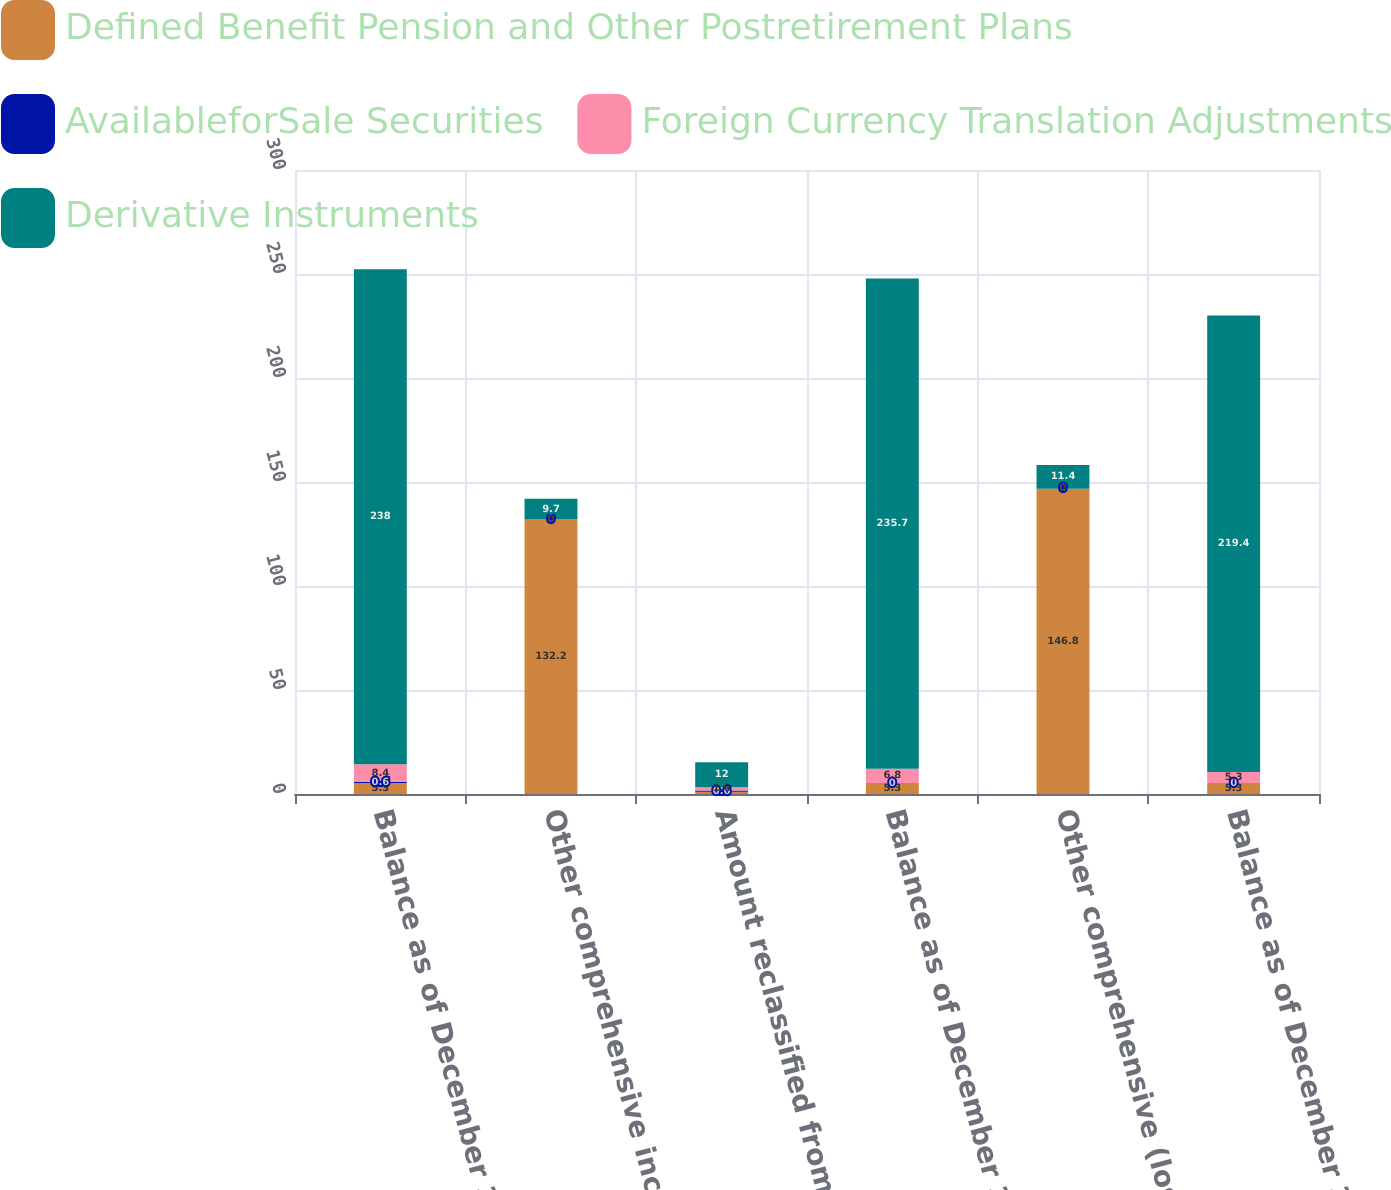Convert chart to OTSL. <chart><loc_0><loc_0><loc_500><loc_500><stacked_bar_chart><ecel><fcel>Balance as of December 31 2016<fcel>Other comprehensive income<fcel>Amount reclassified from<fcel>Balance as of December 31 2017<fcel>Other comprehensive (loss)<fcel>Balance as of December 31 2018<nl><fcel>Defined Benefit Pension and Other Postretirement Plans<fcel>5.3<fcel>132.2<fcel>1.1<fcel>5.3<fcel>146.8<fcel>5.3<nl><fcel>AvailableforSale Securities<fcel>0.6<fcel>0<fcel>0.6<fcel>0<fcel>0<fcel>0<nl><fcel>Foreign Currency Translation Adjustments<fcel>8.4<fcel>0<fcel>1.6<fcel>6.8<fcel>0<fcel>5.3<nl><fcel>Derivative Instruments<fcel>238<fcel>9.7<fcel>12<fcel>235.7<fcel>11.4<fcel>219.4<nl></chart> 